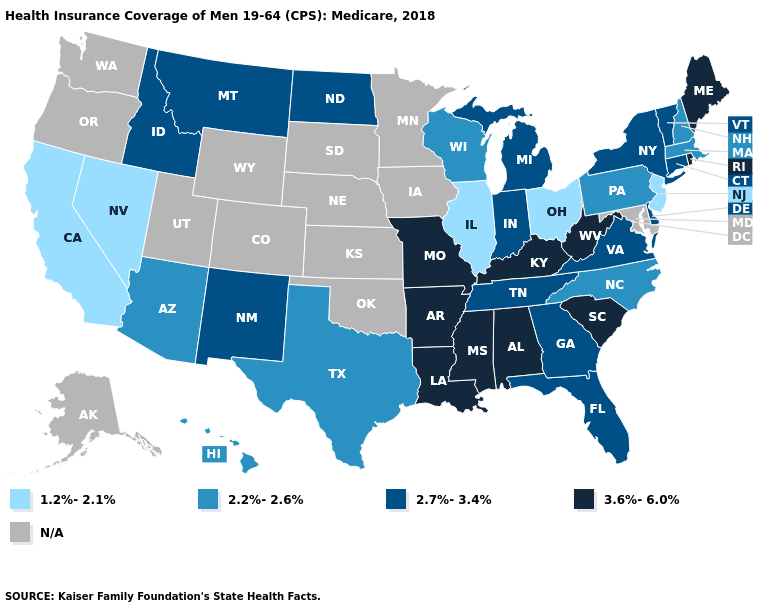Name the states that have a value in the range 2.2%-2.6%?
Write a very short answer. Arizona, Hawaii, Massachusetts, New Hampshire, North Carolina, Pennsylvania, Texas, Wisconsin. Which states have the highest value in the USA?
Short answer required. Alabama, Arkansas, Kentucky, Louisiana, Maine, Mississippi, Missouri, Rhode Island, South Carolina, West Virginia. Does Nevada have the lowest value in the West?
Answer briefly. Yes. What is the value of Louisiana?
Keep it brief. 3.6%-6.0%. What is the value of Minnesota?
Write a very short answer. N/A. Name the states that have a value in the range 3.6%-6.0%?
Concise answer only. Alabama, Arkansas, Kentucky, Louisiana, Maine, Mississippi, Missouri, Rhode Island, South Carolina, West Virginia. Does New Jersey have the lowest value in the USA?
Concise answer only. Yes. Does New Mexico have the lowest value in the USA?
Answer briefly. No. Name the states that have a value in the range 2.7%-3.4%?
Short answer required. Connecticut, Delaware, Florida, Georgia, Idaho, Indiana, Michigan, Montana, New Mexico, New York, North Dakota, Tennessee, Vermont, Virginia. What is the value of Illinois?
Be succinct. 1.2%-2.1%. Does Louisiana have the highest value in the South?
Answer briefly. Yes. What is the value of South Dakota?
Be succinct. N/A. Does Alabama have the highest value in the USA?
Keep it brief. Yes. Name the states that have a value in the range N/A?
Keep it brief. Alaska, Colorado, Iowa, Kansas, Maryland, Minnesota, Nebraska, Oklahoma, Oregon, South Dakota, Utah, Washington, Wyoming. 